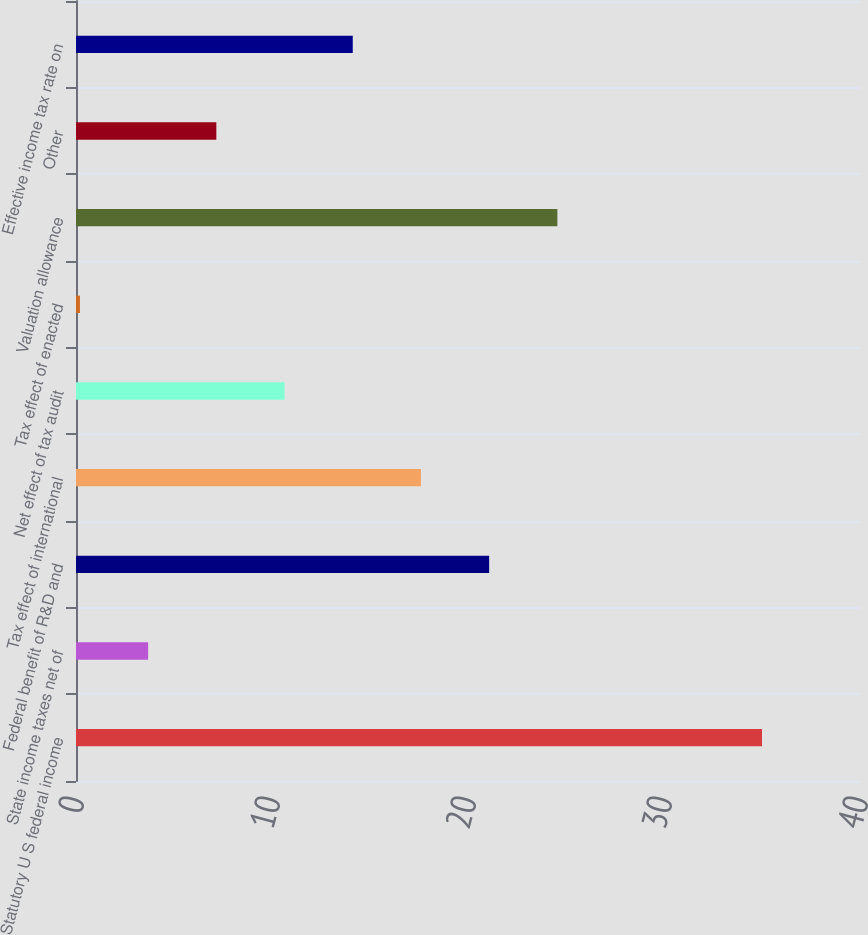<chart> <loc_0><loc_0><loc_500><loc_500><bar_chart><fcel>Statutory U S federal income<fcel>State income taxes net of<fcel>Federal benefit of R&D and<fcel>Tax effect of international<fcel>Net effect of tax audit<fcel>Tax effect of enacted<fcel>Valuation allowance<fcel>Other<fcel>Effective income tax rate on<nl><fcel>35<fcel>3.68<fcel>21.08<fcel>17.6<fcel>10.64<fcel>0.2<fcel>24.56<fcel>7.16<fcel>14.12<nl></chart> 